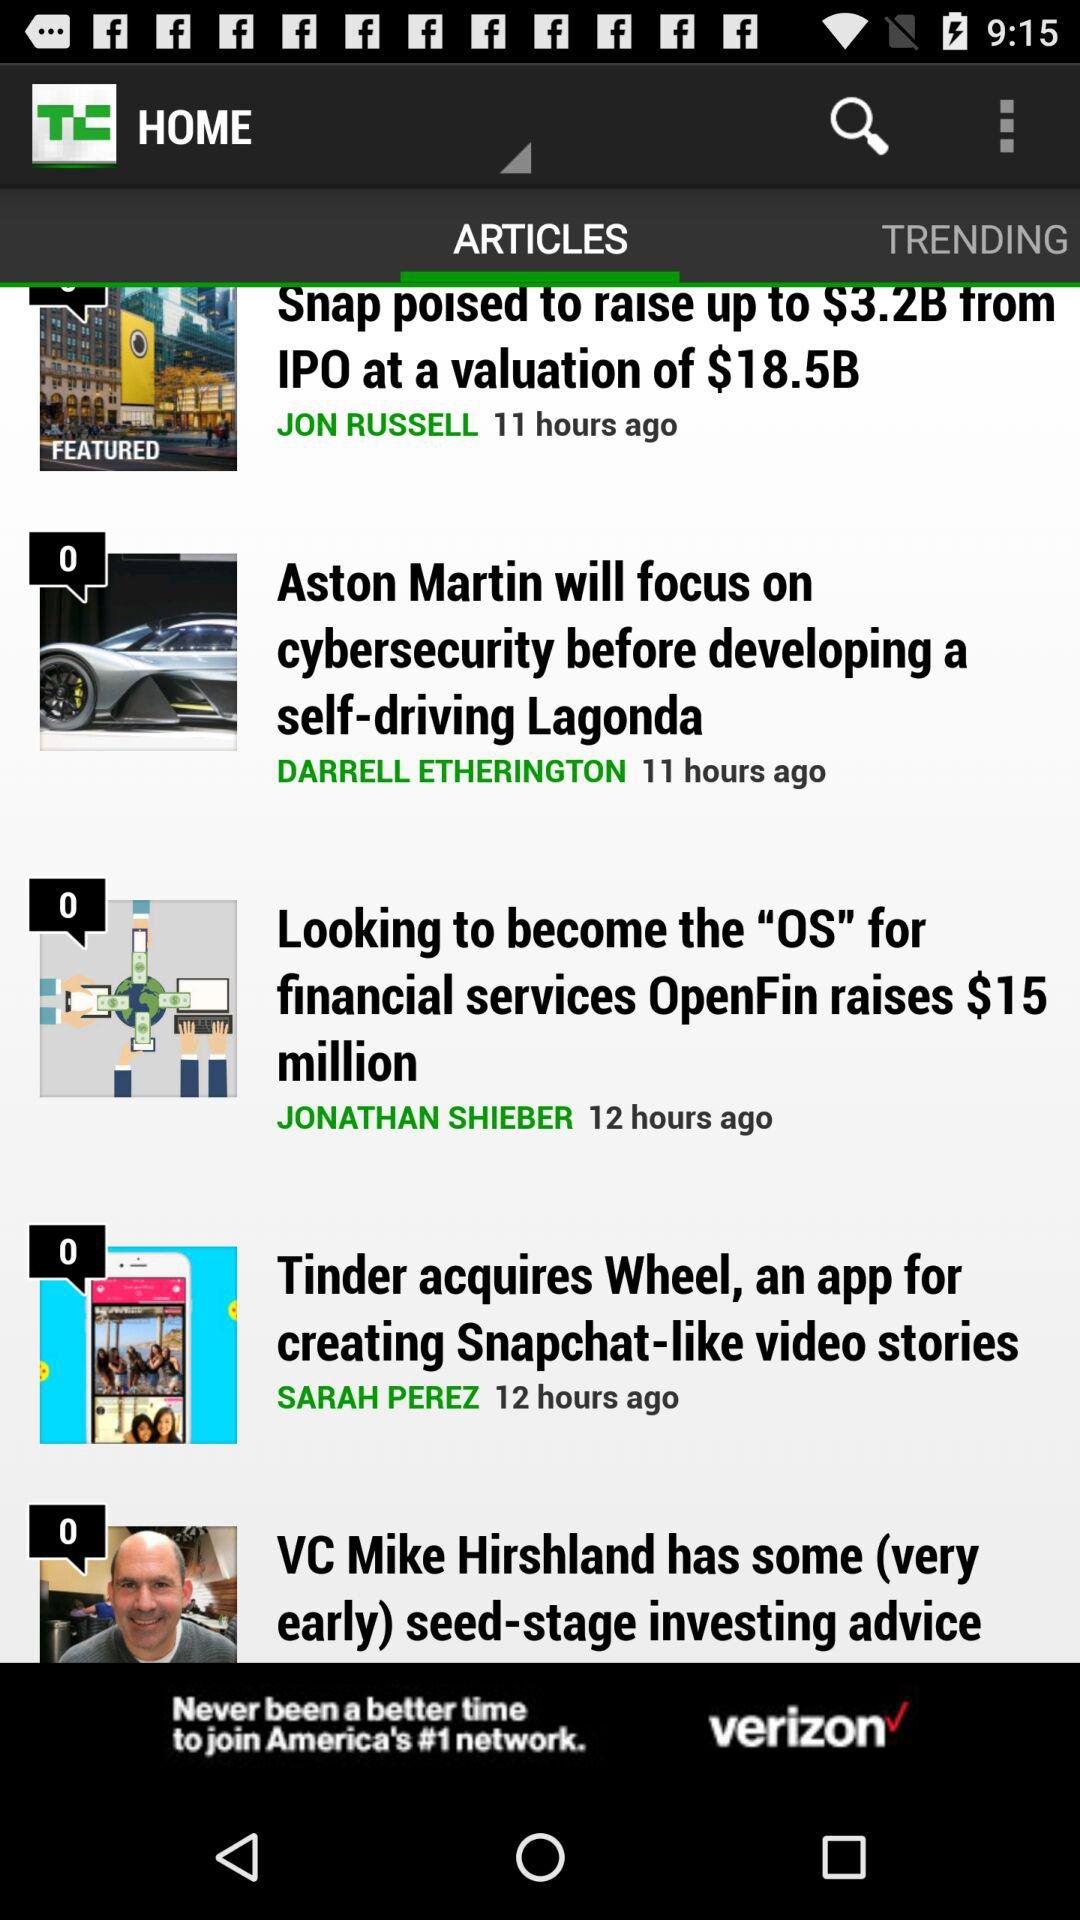Who is the author of the article "Tinder acquires Wheel, an app for creating Snapchat-like video stories"? The author of the article "Tinder acquires Wheel, an app for creating Snapchat-like video stories" is Sarah Perez. 